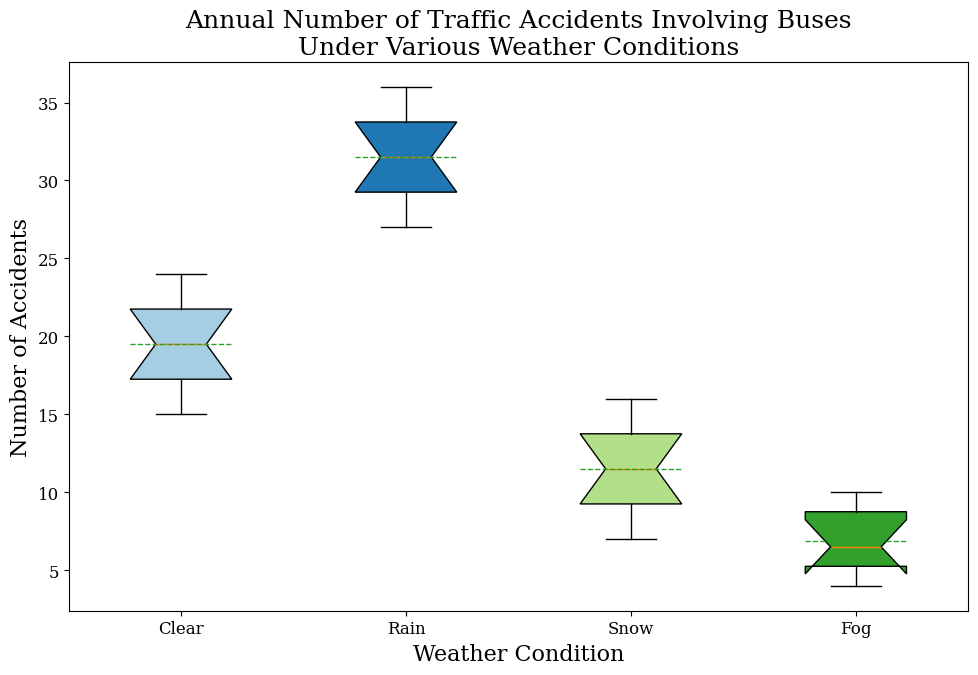Which weather condition has the highest median number of traffic accidents? By examining the plot, we can see that the median is marked along the line within each box. For Rain, the line is the highest among the four conditions.
Answer: Rain Which weather condition has the smallest interquartile range (IQR) for traffic accidents? The IQR is represented by the height of the box. For Fog, this box is the shortest, indicating the smallest IQR.
Answer: Fog What's the difference between the mean number of accidents in Clear and Snow weather conditions? The mean is represented by a dashed line within each box. We identify the mean for Clear and Snow visually and subtract the Snow mean from the Clear mean.
Answer: 4 Which weather condition shows the greatest variation in the number of traffic accidents? Variation can be judged by the distance between the top and bottom whiskers. The box plot for Rain has the longest whiskers, indicating the greatest variation.
Answer: Rain What's the combined median of accidents for Clear and Fog conditions? Find the median value in the box plot for both Clear and Fog and add them together. For Clear, the median is around 19, and for Fog, it's around 7. Combined, this is 26.
Answer: 26 How do the median numbers of accidents in Snow and Fog compare? By looking at the median lines in each box for Snow and Fog, we can see that the median number of accidents in Snow is higher than in Fog.
Answer: Snow is higher What's the range of traffic accidents in Rainy conditions? The range can be identified from the distance between the smallest and largest whiskers in the Rain category. The smallest is 27 and the largest is 36. The range is 36 - 27 = 9.
Answer: 9 Which condition shows the lowest mean number of traffic accidents? By identifying the dashed mean lines in each category, we see the lowest mean is for Fog since its dashed line is closest to the bottom.
Answer: Fog 